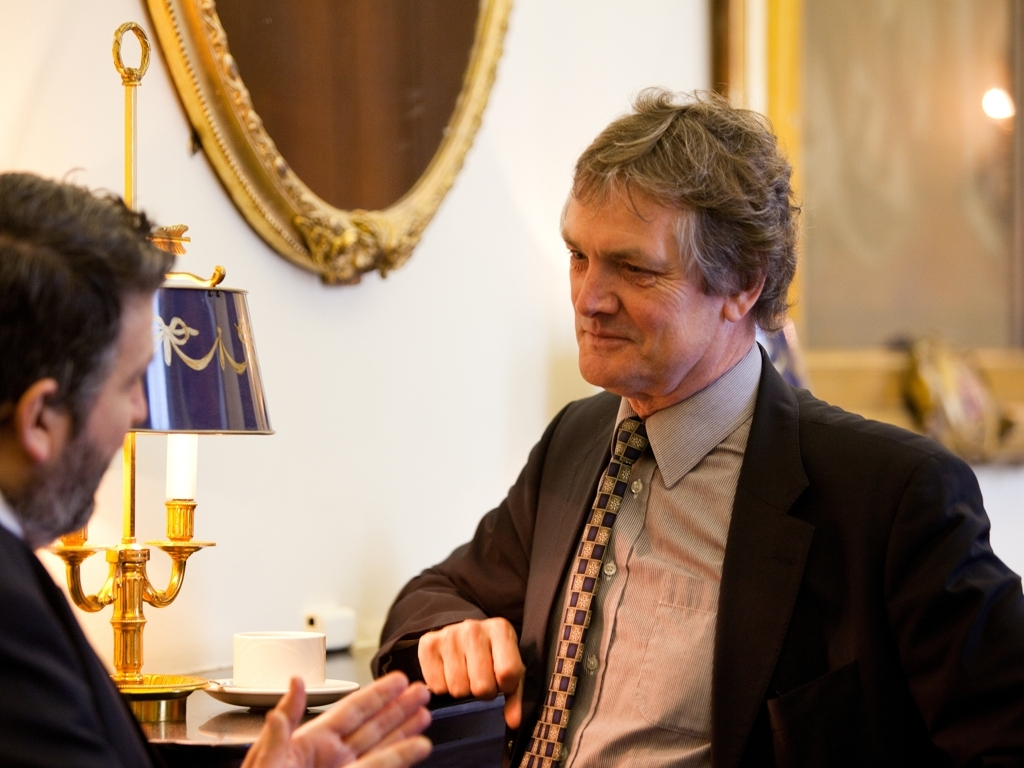What might be the nature of the event or assembly this image is capturing? Given the formal attire of the gentleman in focus and the ornate interior suggesting a refined setting, this image could be capturing a moment from a diplomatic meeting, a formal business discussion, or a high-profile interview. The earnest demeanor of both individuals implies a discussion of substantial importance. 